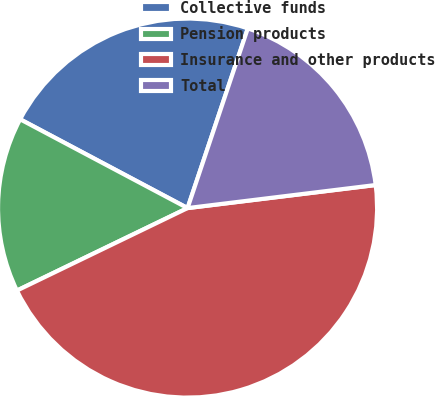Convert chart. <chart><loc_0><loc_0><loc_500><loc_500><pie_chart><fcel>Collective funds<fcel>Pension products<fcel>Insurance and other products<fcel>Total<nl><fcel>22.39%<fcel>14.93%<fcel>44.78%<fcel>17.91%<nl></chart> 